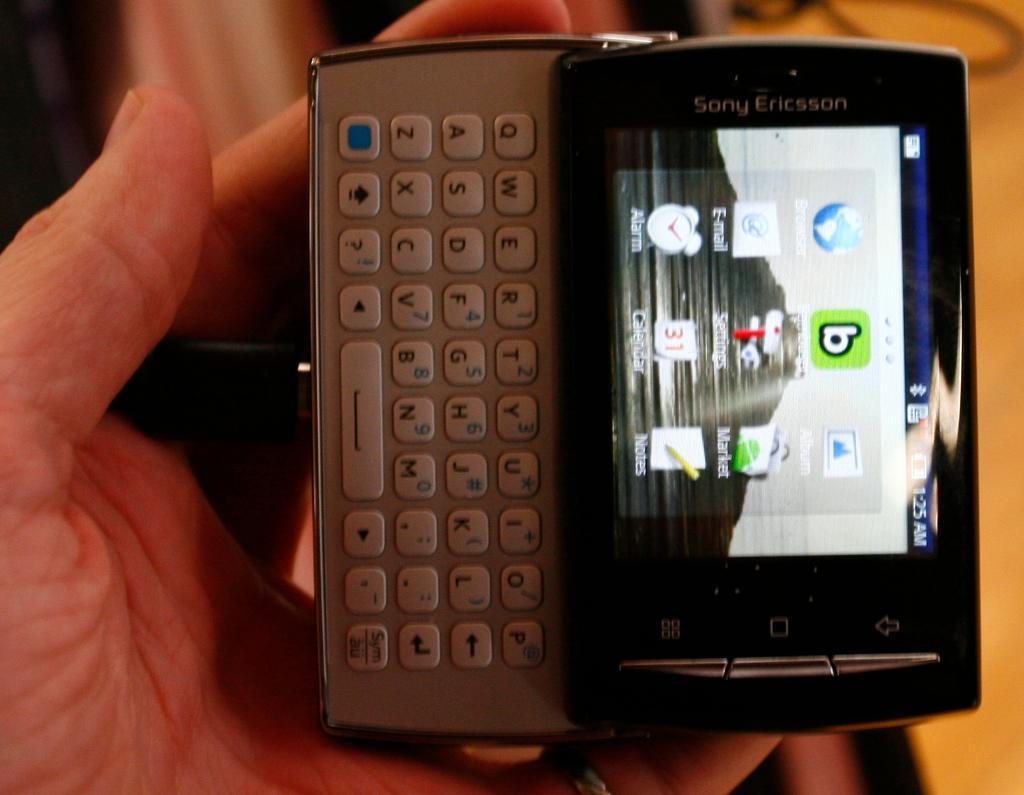What is the brand of the phone?
Your answer should be very brief. Sony ericsson. What time is on the phone?
Provide a succinct answer. 1:25. 